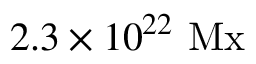Convert formula to latex. <formula><loc_0><loc_0><loc_500><loc_500>2 . 3 \times 1 0 ^ { 2 2 } \ M x</formula> 